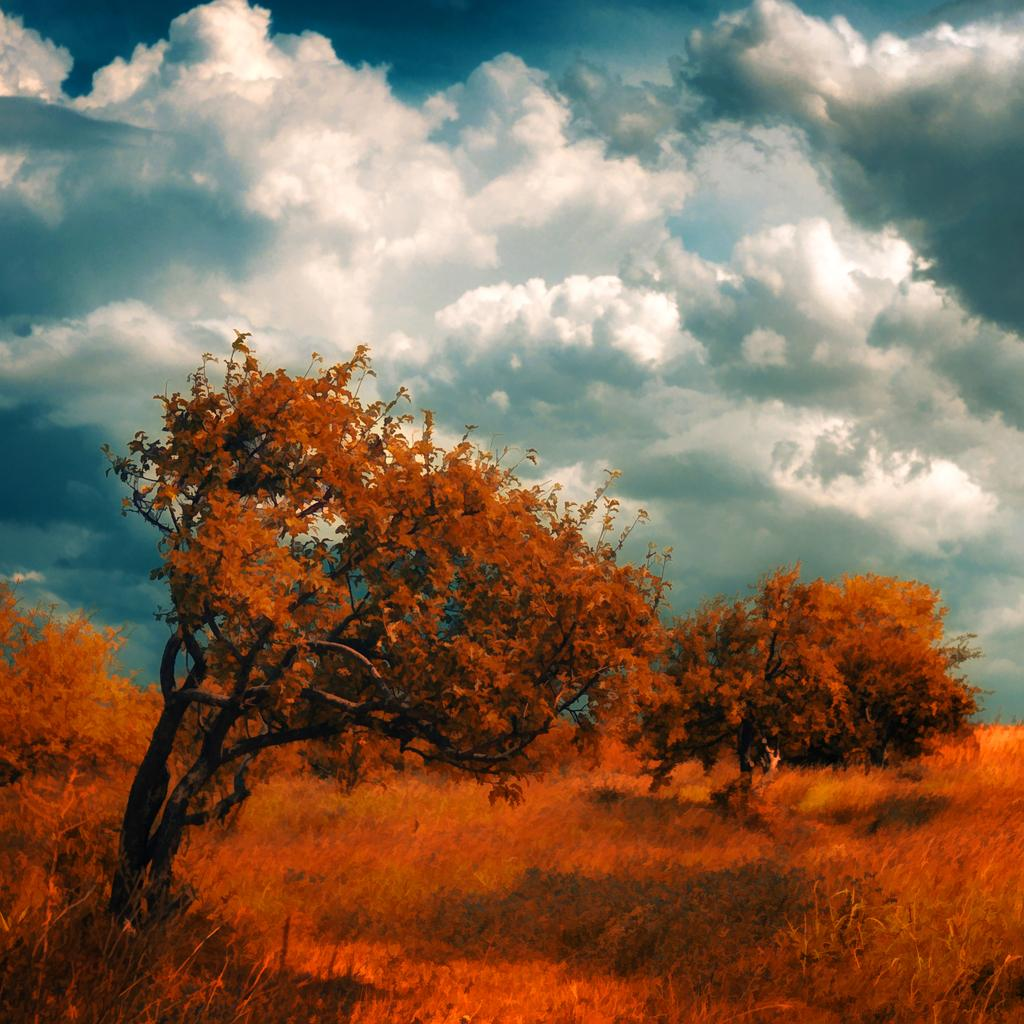What type of vegetation can be seen in the image? There are trees and plants in the image. What is the color of the trees and plants? The trees and plants are orange in color. Where are the trees and plants located in the image? The trees and plants are at the bottom of the image. What can be seen in the sky in the image? The sky has clouds visible in the image. Can you see a lamp hanging from one of the trees in the image? There is no lamp present in the image; it only features trees and plants that are orange in color, located at the bottom of the image, and a sky with clouds. 